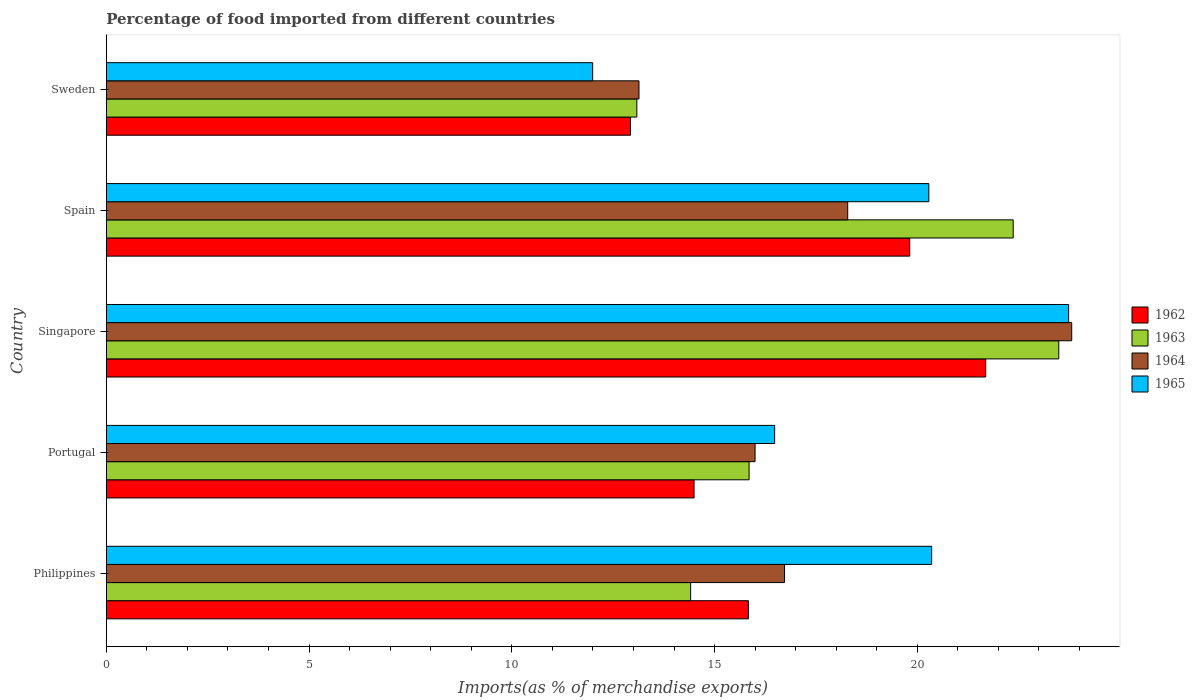Are the number of bars per tick equal to the number of legend labels?
Offer a very short reply. Yes. What is the label of the 2nd group of bars from the top?
Make the answer very short. Spain. In how many cases, is the number of bars for a given country not equal to the number of legend labels?
Keep it short and to the point. 0. What is the percentage of imports to different countries in 1965 in Spain?
Offer a very short reply. 20.28. Across all countries, what is the maximum percentage of imports to different countries in 1963?
Offer a terse response. 23.49. Across all countries, what is the minimum percentage of imports to different countries in 1962?
Keep it short and to the point. 12.93. In which country was the percentage of imports to different countries in 1963 maximum?
Provide a succinct answer. Singapore. What is the total percentage of imports to different countries in 1964 in the graph?
Keep it short and to the point. 87.95. What is the difference between the percentage of imports to different countries in 1963 in Spain and that in Sweden?
Keep it short and to the point. 9.28. What is the difference between the percentage of imports to different countries in 1965 in Portugal and the percentage of imports to different countries in 1962 in Singapore?
Your response must be concise. -5.21. What is the average percentage of imports to different countries in 1965 per country?
Ensure brevity in your answer.  18.57. What is the difference between the percentage of imports to different countries in 1964 and percentage of imports to different countries in 1963 in Sweden?
Make the answer very short. 0.05. In how many countries, is the percentage of imports to different countries in 1965 greater than 13 %?
Your answer should be very brief. 4. What is the ratio of the percentage of imports to different countries in 1964 in Portugal to that in Spain?
Offer a very short reply. 0.88. What is the difference between the highest and the second highest percentage of imports to different countries in 1962?
Make the answer very short. 1.87. What is the difference between the highest and the lowest percentage of imports to different countries in 1963?
Ensure brevity in your answer.  10.41. In how many countries, is the percentage of imports to different countries in 1962 greater than the average percentage of imports to different countries in 1962 taken over all countries?
Offer a terse response. 2. Is the sum of the percentage of imports to different countries in 1963 in Portugal and Singapore greater than the maximum percentage of imports to different countries in 1962 across all countries?
Give a very brief answer. Yes. Is it the case that in every country, the sum of the percentage of imports to different countries in 1962 and percentage of imports to different countries in 1963 is greater than the sum of percentage of imports to different countries in 1964 and percentage of imports to different countries in 1965?
Your answer should be very brief. No. What does the 3rd bar from the top in Portugal represents?
Your answer should be very brief. 1963. What does the 4th bar from the bottom in Sweden represents?
Make the answer very short. 1965. Are all the bars in the graph horizontal?
Your answer should be compact. Yes. How many countries are there in the graph?
Give a very brief answer. 5. What is the difference between two consecutive major ticks on the X-axis?
Your answer should be very brief. 5. Are the values on the major ticks of X-axis written in scientific E-notation?
Offer a very short reply. No. Does the graph contain any zero values?
Offer a terse response. No. How many legend labels are there?
Ensure brevity in your answer.  4. What is the title of the graph?
Provide a succinct answer. Percentage of food imported from different countries. Does "1992" appear as one of the legend labels in the graph?
Offer a very short reply. No. What is the label or title of the X-axis?
Keep it short and to the point. Imports(as % of merchandise exports). What is the label or title of the Y-axis?
Provide a short and direct response. Country. What is the Imports(as % of merchandise exports) of 1962 in Philippines?
Provide a succinct answer. 15.83. What is the Imports(as % of merchandise exports) of 1963 in Philippines?
Ensure brevity in your answer.  14.41. What is the Imports(as % of merchandise exports) in 1964 in Philippines?
Provide a short and direct response. 16.73. What is the Imports(as % of merchandise exports) in 1965 in Philippines?
Give a very brief answer. 20.35. What is the Imports(as % of merchandise exports) of 1962 in Portugal?
Offer a very short reply. 14.49. What is the Imports(as % of merchandise exports) in 1963 in Portugal?
Your response must be concise. 15.85. What is the Imports(as % of merchandise exports) of 1964 in Portugal?
Give a very brief answer. 16. What is the Imports(as % of merchandise exports) of 1965 in Portugal?
Your response must be concise. 16.48. What is the Imports(as % of merchandise exports) of 1962 in Singapore?
Your answer should be compact. 21.69. What is the Imports(as % of merchandise exports) in 1963 in Singapore?
Keep it short and to the point. 23.49. What is the Imports(as % of merchandise exports) in 1964 in Singapore?
Keep it short and to the point. 23.81. What is the Imports(as % of merchandise exports) in 1965 in Singapore?
Your answer should be compact. 23.73. What is the Imports(as % of merchandise exports) of 1962 in Spain?
Give a very brief answer. 19.81. What is the Imports(as % of merchandise exports) in 1963 in Spain?
Offer a terse response. 22.36. What is the Imports(as % of merchandise exports) of 1964 in Spain?
Keep it short and to the point. 18.28. What is the Imports(as % of merchandise exports) in 1965 in Spain?
Give a very brief answer. 20.28. What is the Imports(as % of merchandise exports) of 1962 in Sweden?
Provide a short and direct response. 12.93. What is the Imports(as % of merchandise exports) of 1963 in Sweden?
Provide a succinct answer. 13.08. What is the Imports(as % of merchandise exports) in 1964 in Sweden?
Offer a very short reply. 13.14. What is the Imports(as % of merchandise exports) in 1965 in Sweden?
Your answer should be compact. 11.99. Across all countries, what is the maximum Imports(as % of merchandise exports) of 1962?
Your answer should be very brief. 21.69. Across all countries, what is the maximum Imports(as % of merchandise exports) of 1963?
Provide a succinct answer. 23.49. Across all countries, what is the maximum Imports(as % of merchandise exports) of 1964?
Give a very brief answer. 23.81. Across all countries, what is the maximum Imports(as % of merchandise exports) of 1965?
Ensure brevity in your answer.  23.73. Across all countries, what is the minimum Imports(as % of merchandise exports) of 1962?
Ensure brevity in your answer.  12.93. Across all countries, what is the minimum Imports(as % of merchandise exports) of 1963?
Offer a terse response. 13.08. Across all countries, what is the minimum Imports(as % of merchandise exports) in 1964?
Offer a terse response. 13.14. Across all countries, what is the minimum Imports(as % of merchandise exports) in 1965?
Make the answer very short. 11.99. What is the total Imports(as % of merchandise exports) in 1962 in the graph?
Provide a succinct answer. 84.76. What is the total Imports(as % of merchandise exports) of 1963 in the graph?
Provide a succinct answer. 89.2. What is the total Imports(as % of merchandise exports) in 1964 in the graph?
Offer a terse response. 87.95. What is the total Imports(as % of merchandise exports) of 1965 in the graph?
Provide a short and direct response. 92.85. What is the difference between the Imports(as % of merchandise exports) of 1962 in Philippines and that in Portugal?
Offer a terse response. 1.34. What is the difference between the Imports(as % of merchandise exports) of 1963 in Philippines and that in Portugal?
Ensure brevity in your answer.  -1.44. What is the difference between the Imports(as % of merchandise exports) of 1964 in Philippines and that in Portugal?
Your answer should be compact. 0.73. What is the difference between the Imports(as % of merchandise exports) of 1965 in Philippines and that in Portugal?
Give a very brief answer. 3.87. What is the difference between the Imports(as % of merchandise exports) in 1962 in Philippines and that in Singapore?
Your answer should be compact. -5.85. What is the difference between the Imports(as % of merchandise exports) of 1963 in Philippines and that in Singapore?
Your response must be concise. -9.08. What is the difference between the Imports(as % of merchandise exports) in 1964 in Philippines and that in Singapore?
Provide a succinct answer. -7.08. What is the difference between the Imports(as % of merchandise exports) of 1965 in Philippines and that in Singapore?
Provide a short and direct response. -3.38. What is the difference between the Imports(as % of merchandise exports) of 1962 in Philippines and that in Spain?
Ensure brevity in your answer.  -3.98. What is the difference between the Imports(as % of merchandise exports) of 1963 in Philippines and that in Spain?
Your response must be concise. -7.96. What is the difference between the Imports(as % of merchandise exports) in 1964 in Philippines and that in Spain?
Your response must be concise. -1.56. What is the difference between the Imports(as % of merchandise exports) of 1965 in Philippines and that in Spain?
Offer a terse response. 0.07. What is the difference between the Imports(as % of merchandise exports) of 1962 in Philippines and that in Sweden?
Make the answer very short. 2.91. What is the difference between the Imports(as % of merchandise exports) of 1963 in Philippines and that in Sweden?
Ensure brevity in your answer.  1.33. What is the difference between the Imports(as % of merchandise exports) of 1964 in Philippines and that in Sweden?
Offer a very short reply. 3.59. What is the difference between the Imports(as % of merchandise exports) in 1965 in Philippines and that in Sweden?
Make the answer very short. 8.36. What is the difference between the Imports(as % of merchandise exports) of 1962 in Portugal and that in Singapore?
Keep it short and to the point. -7.19. What is the difference between the Imports(as % of merchandise exports) in 1963 in Portugal and that in Singapore?
Provide a short and direct response. -7.64. What is the difference between the Imports(as % of merchandise exports) in 1964 in Portugal and that in Singapore?
Give a very brief answer. -7.81. What is the difference between the Imports(as % of merchandise exports) of 1965 in Portugal and that in Singapore?
Ensure brevity in your answer.  -7.25. What is the difference between the Imports(as % of merchandise exports) in 1962 in Portugal and that in Spain?
Keep it short and to the point. -5.32. What is the difference between the Imports(as % of merchandise exports) of 1963 in Portugal and that in Spain?
Your answer should be compact. -6.51. What is the difference between the Imports(as % of merchandise exports) of 1964 in Portugal and that in Spain?
Offer a terse response. -2.28. What is the difference between the Imports(as % of merchandise exports) of 1965 in Portugal and that in Spain?
Provide a short and direct response. -3.8. What is the difference between the Imports(as % of merchandise exports) of 1962 in Portugal and that in Sweden?
Ensure brevity in your answer.  1.57. What is the difference between the Imports(as % of merchandise exports) in 1963 in Portugal and that in Sweden?
Give a very brief answer. 2.77. What is the difference between the Imports(as % of merchandise exports) of 1964 in Portugal and that in Sweden?
Provide a short and direct response. 2.86. What is the difference between the Imports(as % of merchandise exports) in 1965 in Portugal and that in Sweden?
Provide a succinct answer. 4.49. What is the difference between the Imports(as % of merchandise exports) of 1962 in Singapore and that in Spain?
Provide a succinct answer. 1.87. What is the difference between the Imports(as % of merchandise exports) of 1963 in Singapore and that in Spain?
Provide a succinct answer. 1.12. What is the difference between the Imports(as % of merchandise exports) in 1964 in Singapore and that in Spain?
Give a very brief answer. 5.52. What is the difference between the Imports(as % of merchandise exports) in 1965 in Singapore and that in Spain?
Offer a terse response. 3.45. What is the difference between the Imports(as % of merchandise exports) of 1962 in Singapore and that in Sweden?
Offer a terse response. 8.76. What is the difference between the Imports(as % of merchandise exports) in 1963 in Singapore and that in Sweden?
Your response must be concise. 10.41. What is the difference between the Imports(as % of merchandise exports) in 1964 in Singapore and that in Sweden?
Keep it short and to the point. 10.67. What is the difference between the Imports(as % of merchandise exports) in 1965 in Singapore and that in Sweden?
Your answer should be compact. 11.74. What is the difference between the Imports(as % of merchandise exports) of 1962 in Spain and that in Sweden?
Give a very brief answer. 6.89. What is the difference between the Imports(as % of merchandise exports) of 1963 in Spain and that in Sweden?
Give a very brief answer. 9.28. What is the difference between the Imports(as % of merchandise exports) of 1964 in Spain and that in Sweden?
Offer a very short reply. 5.15. What is the difference between the Imports(as % of merchandise exports) of 1965 in Spain and that in Sweden?
Your response must be concise. 8.29. What is the difference between the Imports(as % of merchandise exports) in 1962 in Philippines and the Imports(as % of merchandise exports) in 1963 in Portugal?
Ensure brevity in your answer.  -0.02. What is the difference between the Imports(as % of merchandise exports) in 1962 in Philippines and the Imports(as % of merchandise exports) in 1964 in Portugal?
Make the answer very short. -0.16. What is the difference between the Imports(as % of merchandise exports) of 1962 in Philippines and the Imports(as % of merchandise exports) of 1965 in Portugal?
Offer a very short reply. -0.65. What is the difference between the Imports(as % of merchandise exports) of 1963 in Philippines and the Imports(as % of merchandise exports) of 1964 in Portugal?
Offer a very short reply. -1.59. What is the difference between the Imports(as % of merchandise exports) of 1963 in Philippines and the Imports(as % of merchandise exports) of 1965 in Portugal?
Your response must be concise. -2.07. What is the difference between the Imports(as % of merchandise exports) of 1964 in Philippines and the Imports(as % of merchandise exports) of 1965 in Portugal?
Your answer should be very brief. 0.24. What is the difference between the Imports(as % of merchandise exports) in 1962 in Philippines and the Imports(as % of merchandise exports) in 1963 in Singapore?
Offer a terse response. -7.65. What is the difference between the Imports(as % of merchandise exports) of 1962 in Philippines and the Imports(as % of merchandise exports) of 1964 in Singapore?
Your answer should be very brief. -7.97. What is the difference between the Imports(as % of merchandise exports) of 1962 in Philippines and the Imports(as % of merchandise exports) of 1965 in Singapore?
Your response must be concise. -7.9. What is the difference between the Imports(as % of merchandise exports) of 1963 in Philippines and the Imports(as % of merchandise exports) of 1964 in Singapore?
Your answer should be very brief. -9.4. What is the difference between the Imports(as % of merchandise exports) in 1963 in Philippines and the Imports(as % of merchandise exports) in 1965 in Singapore?
Provide a short and direct response. -9.32. What is the difference between the Imports(as % of merchandise exports) in 1964 in Philippines and the Imports(as % of merchandise exports) in 1965 in Singapore?
Offer a very short reply. -7.01. What is the difference between the Imports(as % of merchandise exports) of 1962 in Philippines and the Imports(as % of merchandise exports) of 1963 in Spain?
Offer a very short reply. -6.53. What is the difference between the Imports(as % of merchandise exports) of 1962 in Philippines and the Imports(as % of merchandise exports) of 1964 in Spain?
Keep it short and to the point. -2.45. What is the difference between the Imports(as % of merchandise exports) in 1962 in Philippines and the Imports(as % of merchandise exports) in 1965 in Spain?
Provide a succinct answer. -4.45. What is the difference between the Imports(as % of merchandise exports) in 1963 in Philippines and the Imports(as % of merchandise exports) in 1964 in Spain?
Your answer should be very brief. -3.87. What is the difference between the Imports(as % of merchandise exports) in 1963 in Philippines and the Imports(as % of merchandise exports) in 1965 in Spain?
Provide a succinct answer. -5.88. What is the difference between the Imports(as % of merchandise exports) of 1964 in Philippines and the Imports(as % of merchandise exports) of 1965 in Spain?
Provide a succinct answer. -3.56. What is the difference between the Imports(as % of merchandise exports) in 1962 in Philippines and the Imports(as % of merchandise exports) in 1963 in Sweden?
Your response must be concise. 2.75. What is the difference between the Imports(as % of merchandise exports) of 1962 in Philippines and the Imports(as % of merchandise exports) of 1964 in Sweden?
Make the answer very short. 2.7. What is the difference between the Imports(as % of merchandise exports) of 1962 in Philippines and the Imports(as % of merchandise exports) of 1965 in Sweden?
Ensure brevity in your answer.  3.84. What is the difference between the Imports(as % of merchandise exports) of 1963 in Philippines and the Imports(as % of merchandise exports) of 1964 in Sweden?
Provide a short and direct response. 1.27. What is the difference between the Imports(as % of merchandise exports) in 1963 in Philippines and the Imports(as % of merchandise exports) in 1965 in Sweden?
Ensure brevity in your answer.  2.42. What is the difference between the Imports(as % of merchandise exports) in 1964 in Philippines and the Imports(as % of merchandise exports) in 1965 in Sweden?
Your answer should be very brief. 4.73. What is the difference between the Imports(as % of merchandise exports) in 1962 in Portugal and the Imports(as % of merchandise exports) in 1963 in Singapore?
Ensure brevity in your answer.  -8.99. What is the difference between the Imports(as % of merchandise exports) in 1962 in Portugal and the Imports(as % of merchandise exports) in 1964 in Singapore?
Your answer should be compact. -9.31. What is the difference between the Imports(as % of merchandise exports) of 1962 in Portugal and the Imports(as % of merchandise exports) of 1965 in Singapore?
Offer a terse response. -9.24. What is the difference between the Imports(as % of merchandise exports) in 1963 in Portugal and the Imports(as % of merchandise exports) in 1964 in Singapore?
Your answer should be very brief. -7.96. What is the difference between the Imports(as % of merchandise exports) of 1963 in Portugal and the Imports(as % of merchandise exports) of 1965 in Singapore?
Give a very brief answer. -7.88. What is the difference between the Imports(as % of merchandise exports) in 1964 in Portugal and the Imports(as % of merchandise exports) in 1965 in Singapore?
Provide a short and direct response. -7.73. What is the difference between the Imports(as % of merchandise exports) of 1962 in Portugal and the Imports(as % of merchandise exports) of 1963 in Spain?
Make the answer very short. -7.87. What is the difference between the Imports(as % of merchandise exports) in 1962 in Portugal and the Imports(as % of merchandise exports) in 1964 in Spain?
Your answer should be compact. -3.79. What is the difference between the Imports(as % of merchandise exports) of 1962 in Portugal and the Imports(as % of merchandise exports) of 1965 in Spain?
Your answer should be very brief. -5.79. What is the difference between the Imports(as % of merchandise exports) in 1963 in Portugal and the Imports(as % of merchandise exports) in 1964 in Spain?
Provide a short and direct response. -2.43. What is the difference between the Imports(as % of merchandise exports) in 1963 in Portugal and the Imports(as % of merchandise exports) in 1965 in Spain?
Offer a very short reply. -4.43. What is the difference between the Imports(as % of merchandise exports) of 1964 in Portugal and the Imports(as % of merchandise exports) of 1965 in Spain?
Make the answer very short. -4.29. What is the difference between the Imports(as % of merchandise exports) in 1962 in Portugal and the Imports(as % of merchandise exports) in 1963 in Sweden?
Ensure brevity in your answer.  1.41. What is the difference between the Imports(as % of merchandise exports) in 1962 in Portugal and the Imports(as % of merchandise exports) in 1964 in Sweden?
Give a very brief answer. 1.36. What is the difference between the Imports(as % of merchandise exports) in 1962 in Portugal and the Imports(as % of merchandise exports) in 1965 in Sweden?
Your response must be concise. 2.5. What is the difference between the Imports(as % of merchandise exports) of 1963 in Portugal and the Imports(as % of merchandise exports) of 1964 in Sweden?
Offer a terse response. 2.72. What is the difference between the Imports(as % of merchandise exports) in 1963 in Portugal and the Imports(as % of merchandise exports) in 1965 in Sweden?
Your answer should be very brief. 3.86. What is the difference between the Imports(as % of merchandise exports) of 1964 in Portugal and the Imports(as % of merchandise exports) of 1965 in Sweden?
Provide a short and direct response. 4.01. What is the difference between the Imports(as % of merchandise exports) in 1962 in Singapore and the Imports(as % of merchandise exports) in 1963 in Spain?
Provide a short and direct response. -0.68. What is the difference between the Imports(as % of merchandise exports) of 1962 in Singapore and the Imports(as % of merchandise exports) of 1964 in Spain?
Give a very brief answer. 3.4. What is the difference between the Imports(as % of merchandise exports) in 1962 in Singapore and the Imports(as % of merchandise exports) in 1965 in Spain?
Make the answer very short. 1.4. What is the difference between the Imports(as % of merchandise exports) of 1963 in Singapore and the Imports(as % of merchandise exports) of 1964 in Spain?
Make the answer very short. 5.21. What is the difference between the Imports(as % of merchandise exports) in 1963 in Singapore and the Imports(as % of merchandise exports) in 1965 in Spain?
Provide a short and direct response. 3.2. What is the difference between the Imports(as % of merchandise exports) in 1964 in Singapore and the Imports(as % of merchandise exports) in 1965 in Spain?
Provide a succinct answer. 3.52. What is the difference between the Imports(as % of merchandise exports) of 1962 in Singapore and the Imports(as % of merchandise exports) of 1963 in Sweden?
Keep it short and to the point. 8.6. What is the difference between the Imports(as % of merchandise exports) of 1962 in Singapore and the Imports(as % of merchandise exports) of 1964 in Sweden?
Give a very brief answer. 8.55. What is the difference between the Imports(as % of merchandise exports) in 1962 in Singapore and the Imports(as % of merchandise exports) in 1965 in Sweden?
Your answer should be compact. 9.69. What is the difference between the Imports(as % of merchandise exports) in 1963 in Singapore and the Imports(as % of merchandise exports) in 1964 in Sweden?
Give a very brief answer. 10.35. What is the difference between the Imports(as % of merchandise exports) in 1963 in Singapore and the Imports(as % of merchandise exports) in 1965 in Sweden?
Your response must be concise. 11.5. What is the difference between the Imports(as % of merchandise exports) in 1964 in Singapore and the Imports(as % of merchandise exports) in 1965 in Sweden?
Your answer should be compact. 11.81. What is the difference between the Imports(as % of merchandise exports) in 1962 in Spain and the Imports(as % of merchandise exports) in 1963 in Sweden?
Ensure brevity in your answer.  6.73. What is the difference between the Imports(as % of merchandise exports) in 1962 in Spain and the Imports(as % of merchandise exports) in 1964 in Sweden?
Make the answer very short. 6.68. What is the difference between the Imports(as % of merchandise exports) in 1962 in Spain and the Imports(as % of merchandise exports) in 1965 in Sweden?
Offer a very short reply. 7.82. What is the difference between the Imports(as % of merchandise exports) of 1963 in Spain and the Imports(as % of merchandise exports) of 1964 in Sweden?
Ensure brevity in your answer.  9.23. What is the difference between the Imports(as % of merchandise exports) of 1963 in Spain and the Imports(as % of merchandise exports) of 1965 in Sweden?
Offer a very short reply. 10.37. What is the difference between the Imports(as % of merchandise exports) in 1964 in Spain and the Imports(as % of merchandise exports) in 1965 in Sweden?
Offer a terse response. 6.29. What is the average Imports(as % of merchandise exports) of 1962 per country?
Keep it short and to the point. 16.95. What is the average Imports(as % of merchandise exports) in 1963 per country?
Your answer should be compact. 17.84. What is the average Imports(as % of merchandise exports) of 1964 per country?
Keep it short and to the point. 17.59. What is the average Imports(as % of merchandise exports) in 1965 per country?
Offer a terse response. 18.57. What is the difference between the Imports(as % of merchandise exports) of 1962 and Imports(as % of merchandise exports) of 1963 in Philippines?
Provide a short and direct response. 1.43. What is the difference between the Imports(as % of merchandise exports) of 1962 and Imports(as % of merchandise exports) of 1964 in Philippines?
Offer a very short reply. -0.89. What is the difference between the Imports(as % of merchandise exports) of 1962 and Imports(as % of merchandise exports) of 1965 in Philippines?
Offer a very short reply. -4.52. What is the difference between the Imports(as % of merchandise exports) in 1963 and Imports(as % of merchandise exports) in 1964 in Philippines?
Keep it short and to the point. -2.32. What is the difference between the Imports(as % of merchandise exports) in 1963 and Imports(as % of merchandise exports) in 1965 in Philippines?
Keep it short and to the point. -5.94. What is the difference between the Imports(as % of merchandise exports) in 1964 and Imports(as % of merchandise exports) in 1965 in Philippines?
Give a very brief answer. -3.63. What is the difference between the Imports(as % of merchandise exports) of 1962 and Imports(as % of merchandise exports) of 1963 in Portugal?
Make the answer very short. -1.36. What is the difference between the Imports(as % of merchandise exports) in 1962 and Imports(as % of merchandise exports) in 1964 in Portugal?
Give a very brief answer. -1.5. What is the difference between the Imports(as % of merchandise exports) of 1962 and Imports(as % of merchandise exports) of 1965 in Portugal?
Offer a very short reply. -1.99. What is the difference between the Imports(as % of merchandise exports) in 1963 and Imports(as % of merchandise exports) in 1964 in Portugal?
Keep it short and to the point. -0.15. What is the difference between the Imports(as % of merchandise exports) of 1963 and Imports(as % of merchandise exports) of 1965 in Portugal?
Give a very brief answer. -0.63. What is the difference between the Imports(as % of merchandise exports) in 1964 and Imports(as % of merchandise exports) in 1965 in Portugal?
Your answer should be very brief. -0.48. What is the difference between the Imports(as % of merchandise exports) of 1962 and Imports(as % of merchandise exports) of 1963 in Singapore?
Keep it short and to the point. -1.8. What is the difference between the Imports(as % of merchandise exports) of 1962 and Imports(as % of merchandise exports) of 1964 in Singapore?
Keep it short and to the point. -2.12. What is the difference between the Imports(as % of merchandise exports) of 1962 and Imports(as % of merchandise exports) of 1965 in Singapore?
Your response must be concise. -2.04. What is the difference between the Imports(as % of merchandise exports) in 1963 and Imports(as % of merchandise exports) in 1964 in Singapore?
Your answer should be compact. -0.32. What is the difference between the Imports(as % of merchandise exports) of 1963 and Imports(as % of merchandise exports) of 1965 in Singapore?
Your answer should be compact. -0.24. What is the difference between the Imports(as % of merchandise exports) in 1964 and Imports(as % of merchandise exports) in 1965 in Singapore?
Ensure brevity in your answer.  0.08. What is the difference between the Imports(as % of merchandise exports) in 1962 and Imports(as % of merchandise exports) in 1963 in Spain?
Your response must be concise. -2.55. What is the difference between the Imports(as % of merchandise exports) of 1962 and Imports(as % of merchandise exports) of 1964 in Spain?
Your answer should be compact. 1.53. What is the difference between the Imports(as % of merchandise exports) in 1962 and Imports(as % of merchandise exports) in 1965 in Spain?
Offer a terse response. -0.47. What is the difference between the Imports(as % of merchandise exports) in 1963 and Imports(as % of merchandise exports) in 1964 in Spain?
Offer a terse response. 4.08. What is the difference between the Imports(as % of merchandise exports) of 1963 and Imports(as % of merchandise exports) of 1965 in Spain?
Ensure brevity in your answer.  2.08. What is the difference between the Imports(as % of merchandise exports) of 1964 and Imports(as % of merchandise exports) of 1965 in Spain?
Offer a very short reply. -2. What is the difference between the Imports(as % of merchandise exports) of 1962 and Imports(as % of merchandise exports) of 1963 in Sweden?
Make the answer very short. -0.16. What is the difference between the Imports(as % of merchandise exports) in 1962 and Imports(as % of merchandise exports) in 1964 in Sweden?
Provide a succinct answer. -0.21. What is the difference between the Imports(as % of merchandise exports) of 1962 and Imports(as % of merchandise exports) of 1965 in Sweden?
Provide a succinct answer. 0.93. What is the difference between the Imports(as % of merchandise exports) of 1963 and Imports(as % of merchandise exports) of 1964 in Sweden?
Give a very brief answer. -0.05. What is the difference between the Imports(as % of merchandise exports) of 1963 and Imports(as % of merchandise exports) of 1965 in Sweden?
Give a very brief answer. 1.09. What is the difference between the Imports(as % of merchandise exports) of 1964 and Imports(as % of merchandise exports) of 1965 in Sweden?
Your response must be concise. 1.14. What is the ratio of the Imports(as % of merchandise exports) in 1962 in Philippines to that in Portugal?
Ensure brevity in your answer.  1.09. What is the ratio of the Imports(as % of merchandise exports) of 1963 in Philippines to that in Portugal?
Ensure brevity in your answer.  0.91. What is the ratio of the Imports(as % of merchandise exports) of 1964 in Philippines to that in Portugal?
Keep it short and to the point. 1.05. What is the ratio of the Imports(as % of merchandise exports) in 1965 in Philippines to that in Portugal?
Offer a terse response. 1.24. What is the ratio of the Imports(as % of merchandise exports) in 1962 in Philippines to that in Singapore?
Your answer should be compact. 0.73. What is the ratio of the Imports(as % of merchandise exports) in 1963 in Philippines to that in Singapore?
Make the answer very short. 0.61. What is the ratio of the Imports(as % of merchandise exports) in 1964 in Philippines to that in Singapore?
Your answer should be very brief. 0.7. What is the ratio of the Imports(as % of merchandise exports) in 1965 in Philippines to that in Singapore?
Ensure brevity in your answer.  0.86. What is the ratio of the Imports(as % of merchandise exports) in 1962 in Philippines to that in Spain?
Ensure brevity in your answer.  0.8. What is the ratio of the Imports(as % of merchandise exports) in 1963 in Philippines to that in Spain?
Provide a short and direct response. 0.64. What is the ratio of the Imports(as % of merchandise exports) of 1964 in Philippines to that in Spain?
Your response must be concise. 0.91. What is the ratio of the Imports(as % of merchandise exports) of 1962 in Philippines to that in Sweden?
Provide a succinct answer. 1.22. What is the ratio of the Imports(as % of merchandise exports) in 1963 in Philippines to that in Sweden?
Your response must be concise. 1.1. What is the ratio of the Imports(as % of merchandise exports) of 1964 in Philippines to that in Sweden?
Ensure brevity in your answer.  1.27. What is the ratio of the Imports(as % of merchandise exports) of 1965 in Philippines to that in Sweden?
Your response must be concise. 1.7. What is the ratio of the Imports(as % of merchandise exports) of 1962 in Portugal to that in Singapore?
Your answer should be compact. 0.67. What is the ratio of the Imports(as % of merchandise exports) of 1963 in Portugal to that in Singapore?
Your answer should be compact. 0.67. What is the ratio of the Imports(as % of merchandise exports) in 1964 in Portugal to that in Singapore?
Your answer should be very brief. 0.67. What is the ratio of the Imports(as % of merchandise exports) of 1965 in Portugal to that in Singapore?
Your answer should be very brief. 0.69. What is the ratio of the Imports(as % of merchandise exports) in 1962 in Portugal to that in Spain?
Your answer should be compact. 0.73. What is the ratio of the Imports(as % of merchandise exports) of 1963 in Portugal to that in Spain?
Provide a short and direct response. 0.71. What is the ratio of the Imports(as % of merchandise exports) of 1965 in Portugal to that in Spain?
Give a very brief answer. 0.81. What is the ratio of the Imports(as % of merchandise exports) in 1962 in Portugal to that in Sweden?
Provide a short and direct response. 1.12. What is the ratio of the Imports(as % of merchandise exports) in 1963 in Portugal to that in Sweden?
Make the answer very short. 1.21. What is the ratio of the Imports(as % of merchandise exports) in 1964 in Portugal to that in Sweden?
Provide a succinct answer. 1.22. What is the ratio of the Imports(as % of merchandise exports) in 1965 in Portugal to that in Sweden?
Ensure brevity in your answer.  1.37. What is the ratio of the Imports(as % of merchandise exports) of 1962 in Singapore to that in Spain?
Offer a very short reply. 1.09. What is the ratio of the Imports(as % of merchandise exports) of 1963 in Singapore to that in Spain?
Provide a short and direct response. 1.05. What is the ratio of the Imports(as % of merchandise exports) of 1964 in Singapore to that in Spain?
Ensure brevity in your answer.  1.3. What is the ratio of the Imports(as % of merchandise exports) in 1965 in Singapore to that in Spain?
Your answer should be compact. 1.17. What is the ratio of the Imports(as % of merchandise exports) of 1962 in Singapore to that in Sweden?
Provide a short and direct response. 1.68. What is the ratio of the Imports(as % of merchandise exports) of 1963 in Singapore to that in Sweden?
Your response must be concise. 1.8. What is the ratio of the Imports(as % of merchandise exports) in 1964 in Singapore to that in Sweden?
Offer a very short reply. 1.81. What is the ratio of the Imports(as % of merchandise exports) in 1965 in Singapore to that in Sweden?
Provide a succinct answer. 1.98. What is the ratio of the Imports(as % of merchandise exports) of 1962 in Spain to that in Sweden?
Make the answer very short. 1.53. What is the ratio of the Imports(as % of merchandise exports) of 1963 in Spain to that in Sweden?
Your response must be concise. 1.71. What is the ratio of the Imports(as % of merchandise exports) of 1964 in Spain to that in Sweden?
Your answer should be compact. 1.39. What is the ratio of the Imports(as % of merchandise exports) of 1965 in Spain to that in Sweden?
Your answer should be very brief. 1.69. What is the difference between the highest and the second highest Imports(as % of merchandise exports) of 1962?
Make the answer very short. 1.87. What is the difference between the highest and the second highest Imports(as % of merchandise exports) in 1963?
Provide a short and direct response. 1.12. What is the difference between the highest and the second highest Imports(as % of merchandise exports) of 1964?
Offer a terse response. 5.52. What is the difference between the highest and the second highest Imports(as % of merchandise exports) of 1965?
Keep it short and to the point. 3.38. What is the difference between the highest and the lowest Imports(as % of merchandise exports) of 1962?
Your response must be concise. 8.76. What is the difference between the highest and the lowest Imports(as % of merchandise exports) of 1963?
Your answer should be compact. 10.41. What is the difference between the highest and the lowest Imports(as % of merchandise exports) of 1964?
Offer a very short reply. 10.67. What is the difference between the highest and the lowest Imports(as % of merchandise exports) of 1965?
Ensure brevity in your answer.  11.74. 